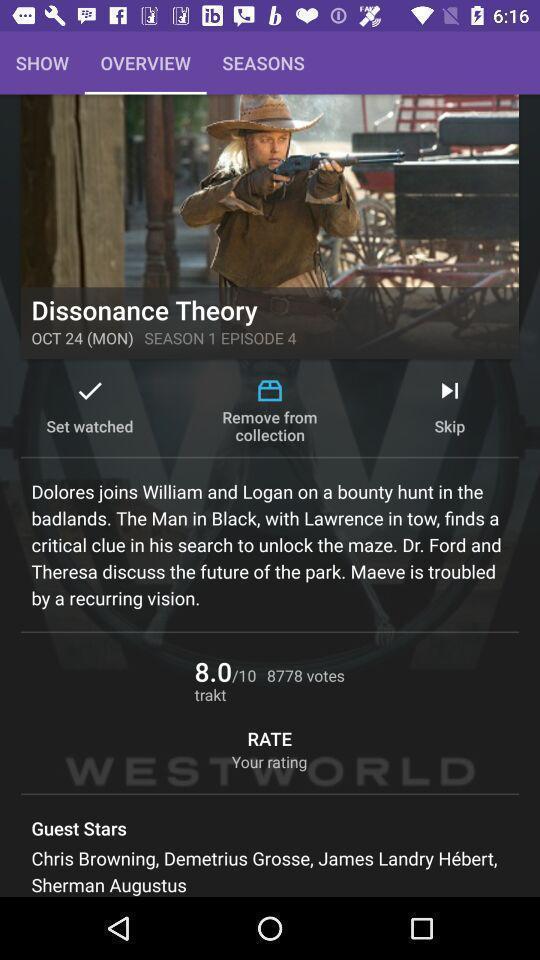Explain what's happening in this screen capture. Page displaying for entertainment app. 